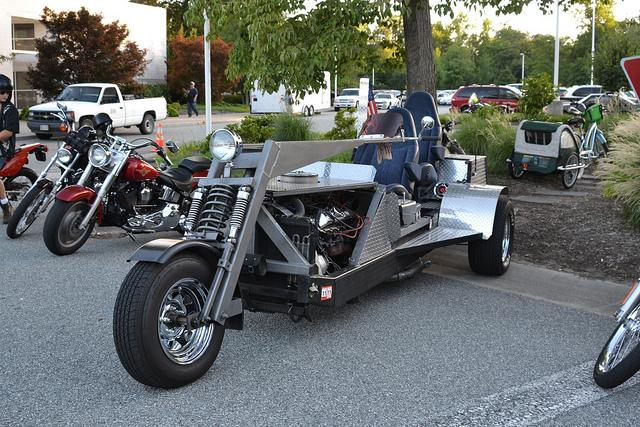How many cylinders does the engine in this custom tricycle have?

Choices:
A) six
B) eight
C) four
D) 12 eight 